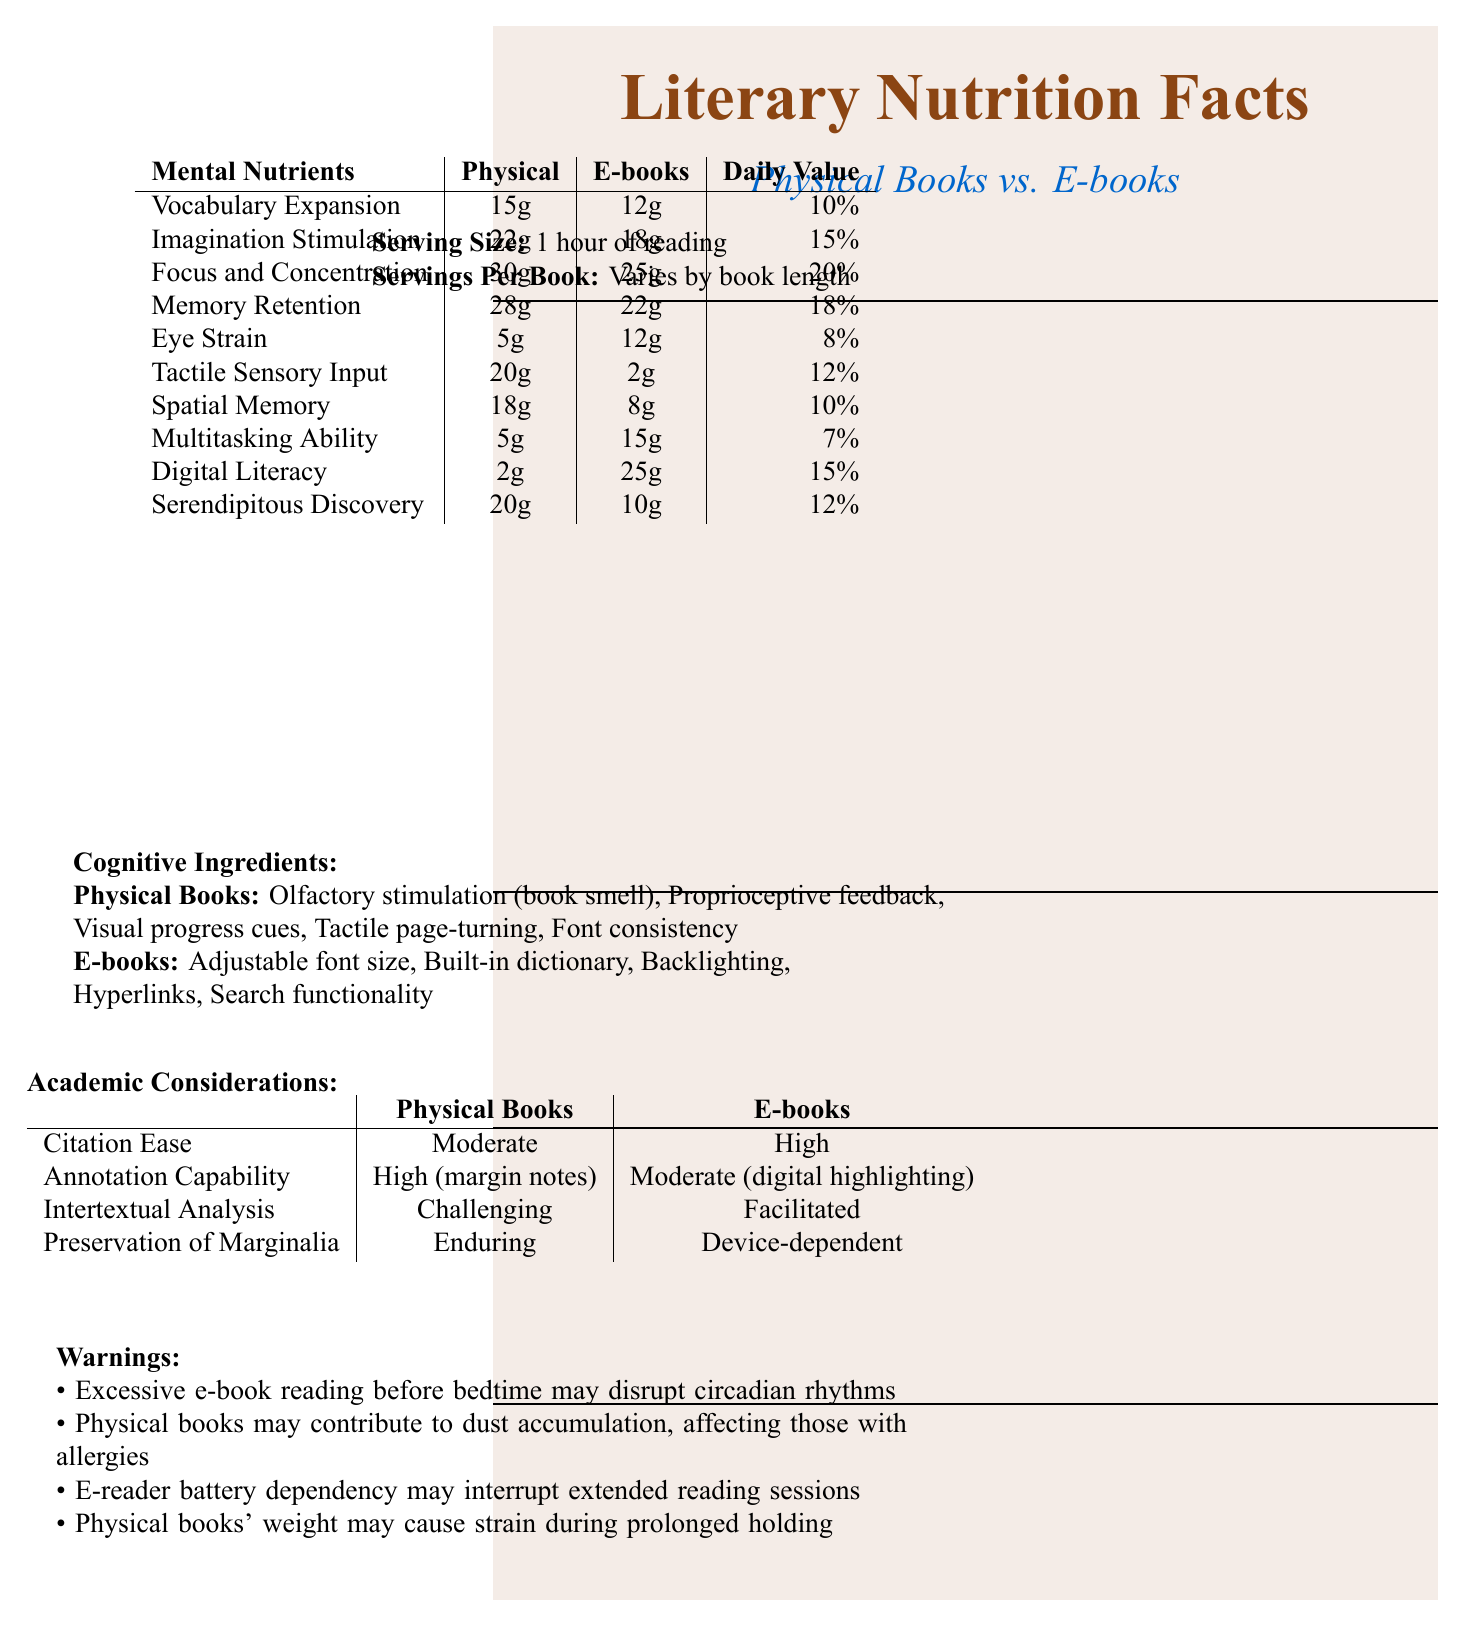What is the serving size mentioned in the document? The serving size is clearly stated at the start of the document under "Serving Size."
Answer: 1 hour of reading How does Vocabulary Expansion differ between physical books and e-books? The document lists Vocabulary Expansion under Mental Nutrients, providing the values for both physical books and e-books.
Answer: 15g for Physical Books and 12g for E-books Which type of book has a higher daily value percentage for Imagination Stimulation? The Daily Value for Imagination Stimulation is 15% for both Physical Books and E-books, as indicated in the Mental Nutrients section.
Answer: Physical Books Which type of book offers more Tactile Sensory Input? The document lists Tactile Sensory Input of 20g for Physical Books and 2g for E-books under Mental Nutrients.
Answer: Physical Books Can Marginalia be preserved better in physical books or e-books? Under Academic Considerations, the document states that the Preservation of Marginalia is enduring for Physical Books but device-dependent for E-books.
Answer: Physical Books What are some advantages of e-books listed in the document? These advantages are listed under Cognitive Ingredients for E-books.
Answer: Adjustable font size, Built-in dictionary, Backlighting, Hyperlinks, Search functionality Which type of book is noted for potentially causing more eye strain? A. Physical Books B. E-books C. Both equally The Eye Strain for E-books is 12g, while for Physical Books it is only 5g, as shown in the Mental Nutrients section.
Answer: B (E-books) What is the main idea of the document? The document uses a creative format to present a comparison between physical books and e-books, highlighting various mental and cognitive effects of reading both types of books.
Answer: The document compares the cognitive benefits and drawbacks of reading physical books versus e-books, using a nutrition facts label format to detail various mental nutrients, cognitive ingredients, academic considerations, and warnings. Which type of book facilitates intertextual analysis better? Under Academic Considerations, the document mentions that Intertextual Analysis is facilitated with E-books and challenging with Physical Books.
Answer: E-books Does reading physical books contribute to Digital Literacy? The document lists Digital Literacy at 2g for Physical Books and 25g for E-books in the Mental Nutrients section.
Answer: Yes, but minimally According to the document, which type of book is more suitable for multitasking ability? A. Physical Books B. E-books C. Both equally The Mental Nutrients section lists Multitasking Ability at 15g for E-books and 5g for Physical Books.
Answer: B (E-books) What is one warning mentioned about physical books? This warning is listed under the Warnings section of the document.
Answer: Physical books may contribute to dust accumulation, affecting those with allergies. Are physical books and e-books mentioned as equally beneficial for daily value percentages in any mental nutrient categories? The document specifies different daily value percentages for each mental nutrient for physical books and e-books, making them not equal in any category.
Answer: No What are the visual progress cues mentioned in the Cognitive Ingredients section for physical books? The document lists visual progress cues specifically under Cognitive Ingredients for physical books.
Answer: Visual progress cues Is it true that excessive e-book reading before bedtime may disrupt circadian rhythms? This is listed as a warning in the document.
Answer: True Which type of book offers better citation ease according to the document? A. Physical Books B. E-books C. Both equally Under Academic Considerations, Citation Ease is marked as High for E-books and Moderate for Physical Books.
Answer: B (E-books) What cognitive benefit has a daily value of 20% for physical books? The document lists the daily value of Focus and Concentration at 20% in the Mental Nutrients section.
Answer: Focus and Concentration Do e-books provide any proprioceptive feedback according to the document? Proprioceptive feedback is listed under Cognitive Ingredients specifically for Physical Books, not E-books.
Answer: No Which type of book has a higher value for Serendipitous Discovery? The Mental Nutrients section shows Serendipitous Discovery at 20g for Physical Books and 10g for E-books.
Answer: Physical Books Can we determine the exact number of servings per book from the document? The document states "Varies by book length" under Servings Per Book without providing exact numbers.
Answer: Cannot be determined 